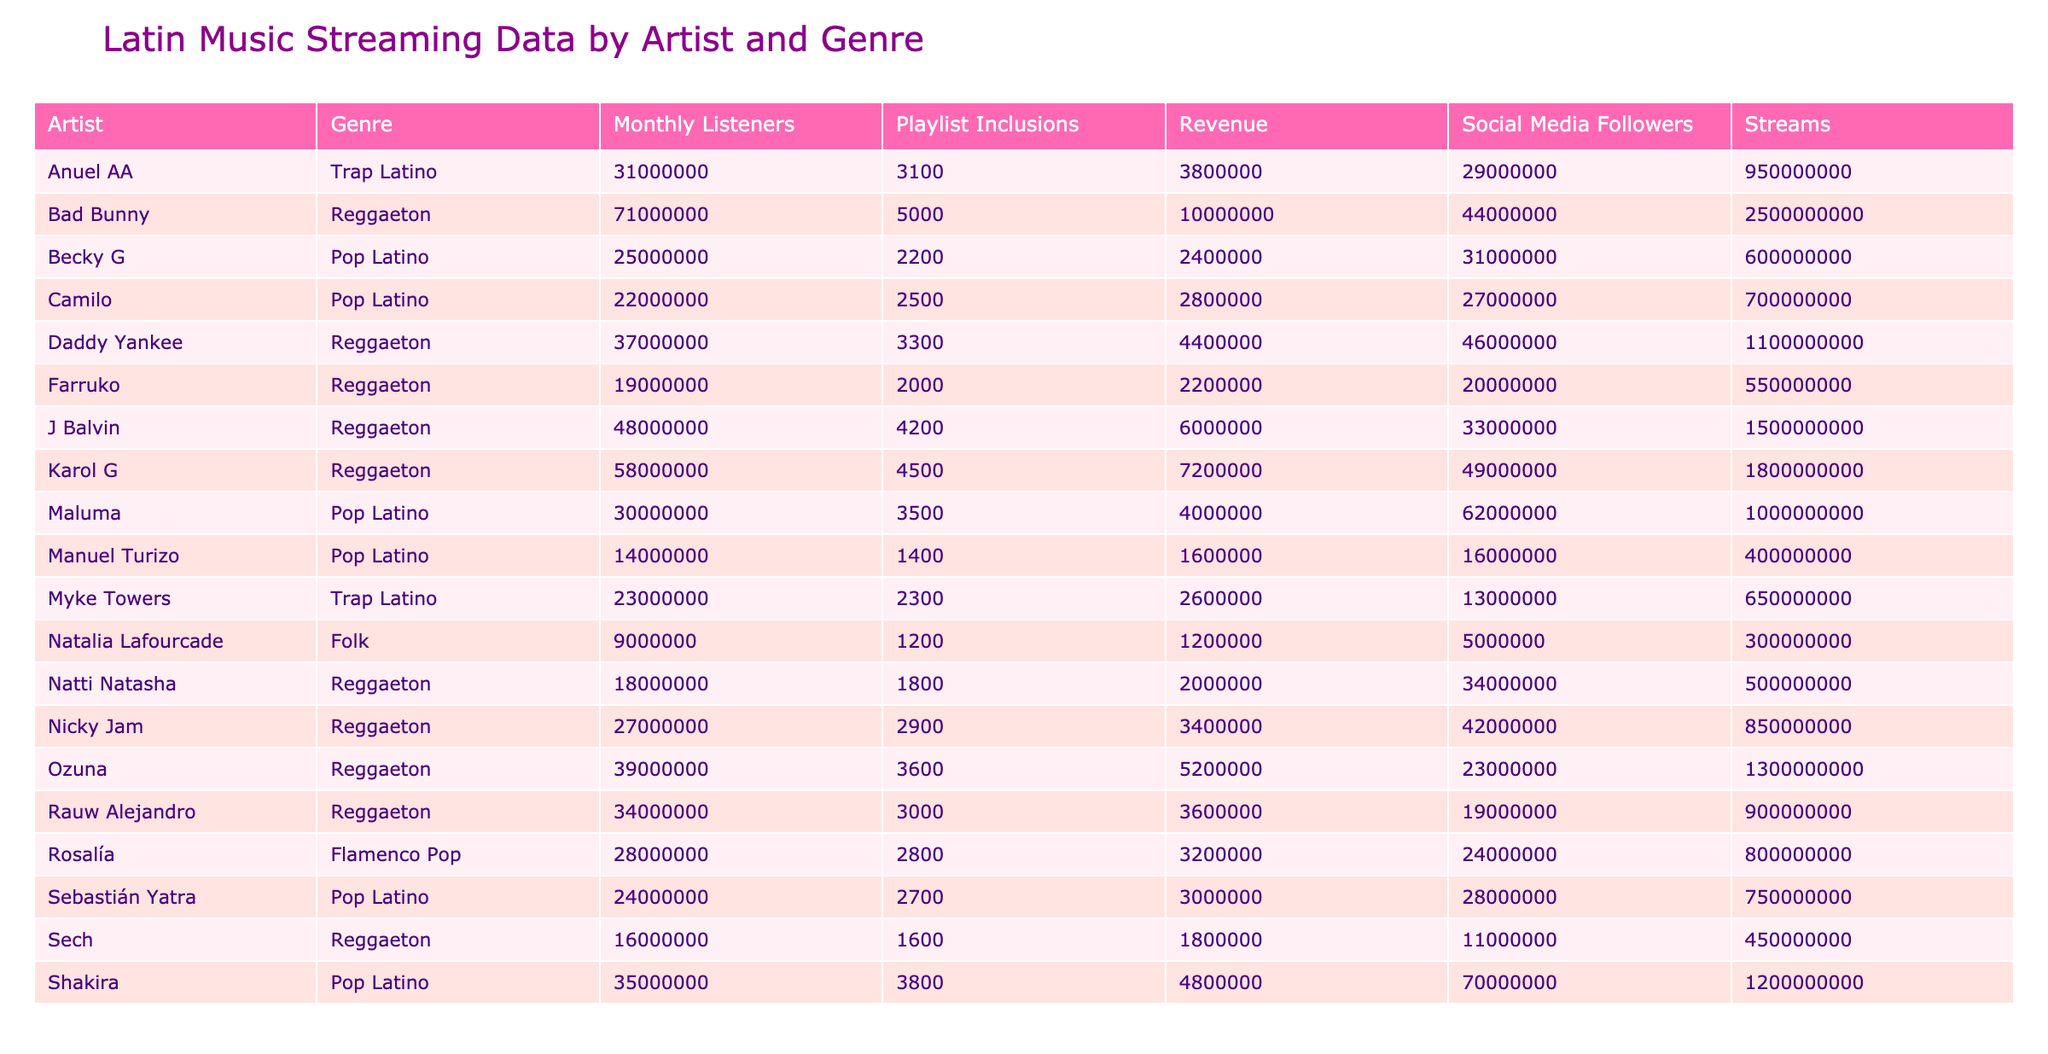What artist had the highest number of streams? By examining the Streams column, Bad Bunny is listed with 2,500,000,000 streams, more than any other artist in the table.
Answer: Bad Bunny Which genre had the most total revenue generated? To find this, I must sum the revenue for each genre: Reggaeton (10,000,000 + 7,200,000 + 6,000,000 + 5,200,000 + 4,400,000 + 3,600,000 + 2,200,000 + 3,400,000 + 1,800,000 = 43,800,000), Pop Latino (4,800,000 + 2,800,000 + 2,400,000 + 3,000,000 + 1,600,000 = 15,600,000), Flamenco Pop (3,200,000), and Trap Latino (3,800,000 + 2,600,000 = 6,400,000). So, Reggaeton has the highest.
Answer: Reggaeton Did Shakira have more streams than Maluma? Comparing the Streams column, Shakira has 1,200,000,000 streams and Maluma has 1,000,000,000 streams. Since 1,200,000,000 is greater than 1,000,000,000, the statement is true.
Answer: Yes What is the average number of playlist inclusions for all artists in Reggaeton? To calculate the average for Reggaeton, I can find the sum of playlist inclusions (5000 + 4500 + 4200 + 3600 + 3300 + 3000 + 1800 + 2200 = 36,600) and divide it by the number of Reggaeton artists (8). The average is 36,600 / 8 = 4,575.
Answer: 4,575 Which country has the highest total streams? I need to sum the total streams per country: Puerto Rico (2,500,000,000 + 900,000,000 + 1,300,000,000 + 1,100,000,000 + 650,000,000 + 550,000,000 = 7,000,000,000), Colombia (1,800,000,000 + 1,200,000,000 + 1,500,000,000 + 700,000,000 + 750,000,000 = 7,000,000,000), Dominican Republic (500,000,000), United States (600,000,000 + 850,000,000 = 1,450,000,000), Spain (800,000,000), and Panama (450,000,000). Puerto Rico and Colombia have the same total streams.
Answer: Puerto Rico and Colombia Is there an artist from Spain in the table? The table lists Rosalía, who is identified as being from Spain. Therefore, the answer must be true.
Answer: Yes 